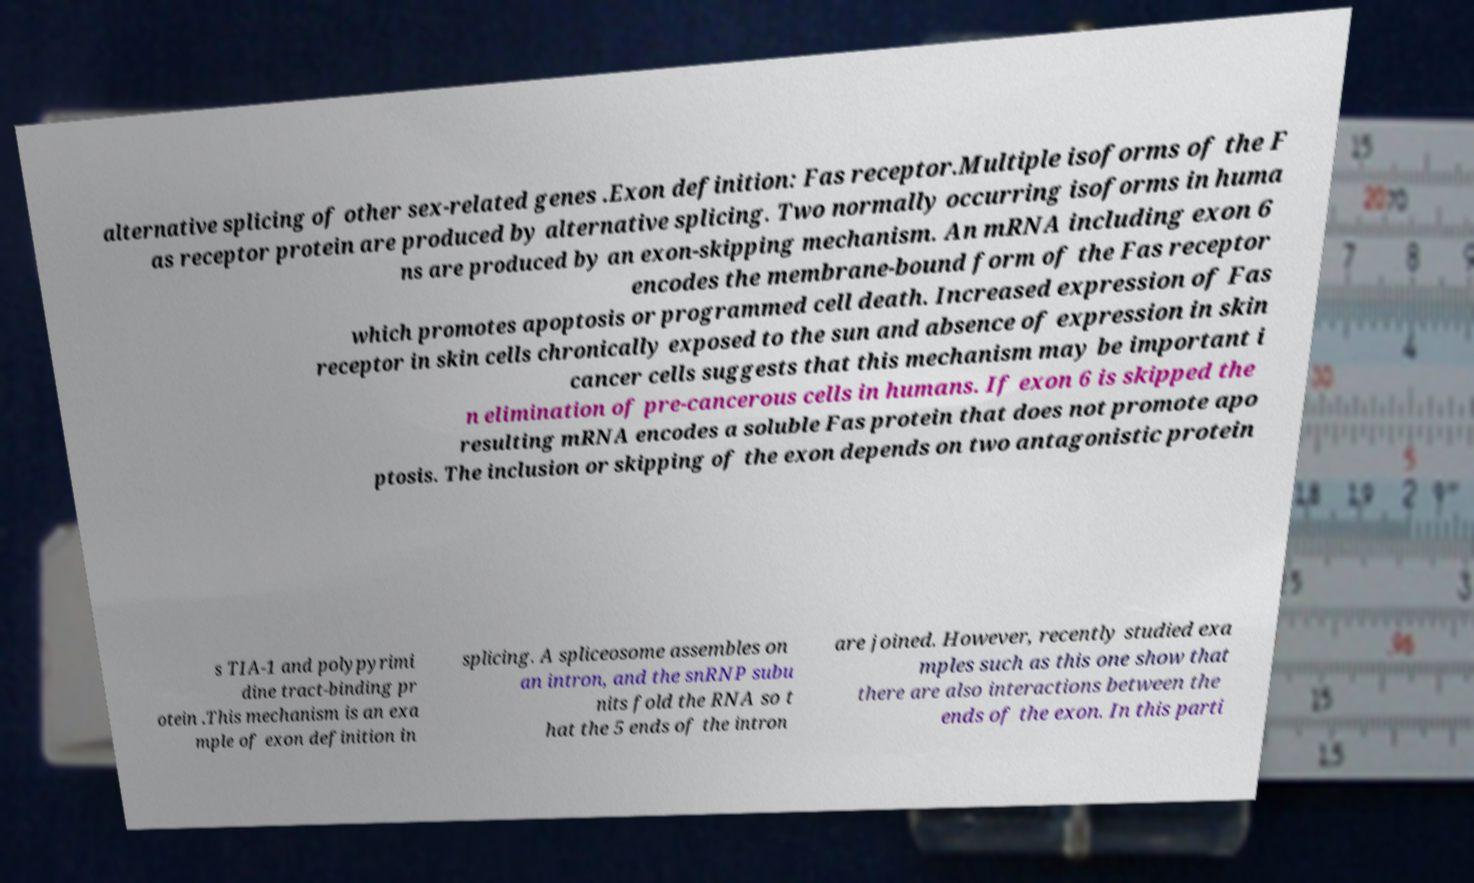Please identify and transcribe the text found in this image. alternative splicing of other sex-related genes .Exon definition: Fas receptor.Multiple isoforms of the F as receptor protein are produced by alternative splicing. Two normally occurring isoforms in huma ns are produced by an exon-skipping mechanism. An mRNA including exon 6 encodes the membrane-bound form of the Fas receptor which promotes apoptosis or programmed cell death. Increased expression of Fas receptor in skin cells chronically exposed to the sun and absence of expression in skin cancer cells suggests that this mechanism may be important i n elimination of pre-cancerous cells in humans. If exon 6 is skipped the resulting mRNA encodes a soluble Fas protein that does not promote apo ptosis. The inclusion or skipping of the exon depends on two antagonistic protein s TIA-1 and polypyrimi dine tract-binding pr otein .This mechanism is an exa mple of exon definition in splicing. A spliceosome assembles on an intron, and the snRNP subu nits fold the RNA so t hat the 5 ends of the intron are joined. However, recently studied exa mples such as this one show that there are also interactions between the ends of the exon. In this parti 